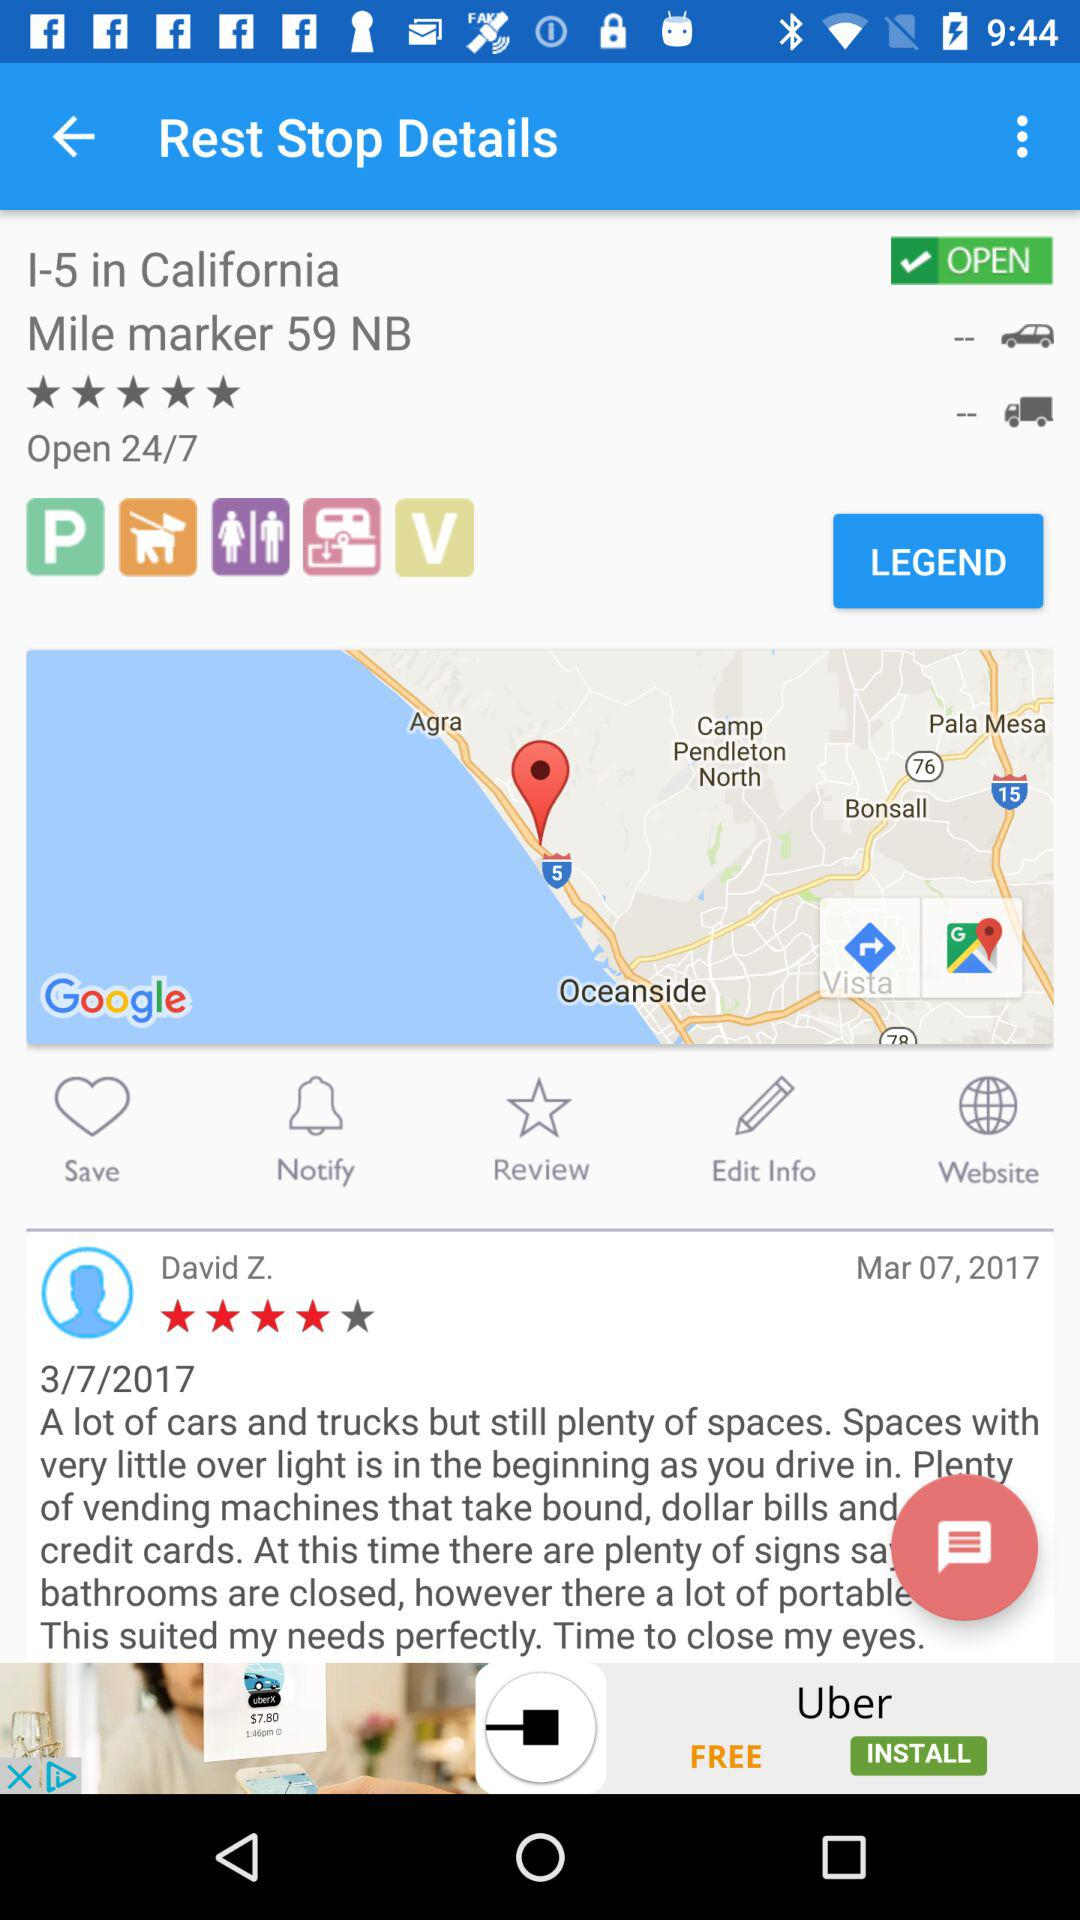What is the name of the person who wrote the review?
Answer the question using a single word or phrase. David Z. 